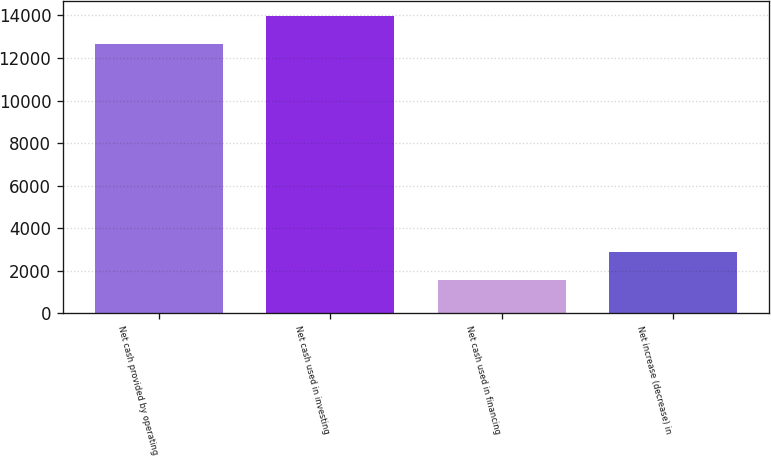<chart> <loc_0><loc_0><loc_500><loc_500><bar_chart><fcel>Net cash provided by operating<fcel>Net cash used in investing<fcel>Net cash used in financing<fcel>Net increase (decrease) in<nl><fcel>12639<fcel>13959<fcel>1566<fcel>2886<nl></chart> 